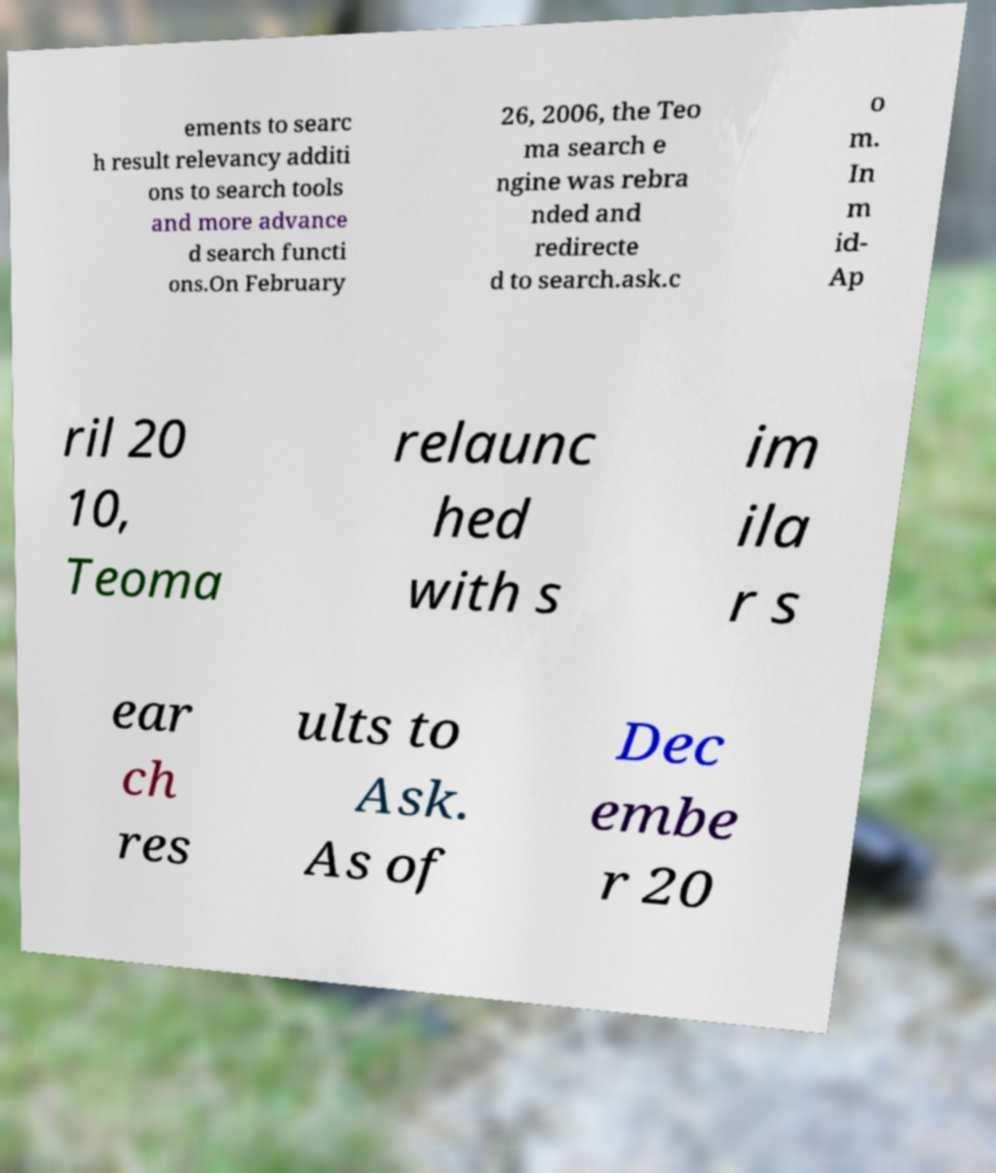Please read and relay the text visible in this image. What does it say? ements to searc h result relevancy additi ons to search tools and more advance d search functi ons.On February 26, 2006, the Teo ma search e ngine was rebra nded and redirecte d to search.ask.c o m. In m id- Ap ril 20 10, Teoma relaunc hed with s im ila r s ear ch res ults to Ask. As of Dec embe r 20 